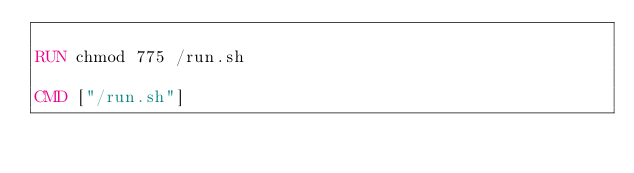<code> <loc_0><loc_0><loc_500><loc_500><_Dockerfile_>
RUN chmod 775 /run.sh

CMD ["/run.sh"]
</code> 